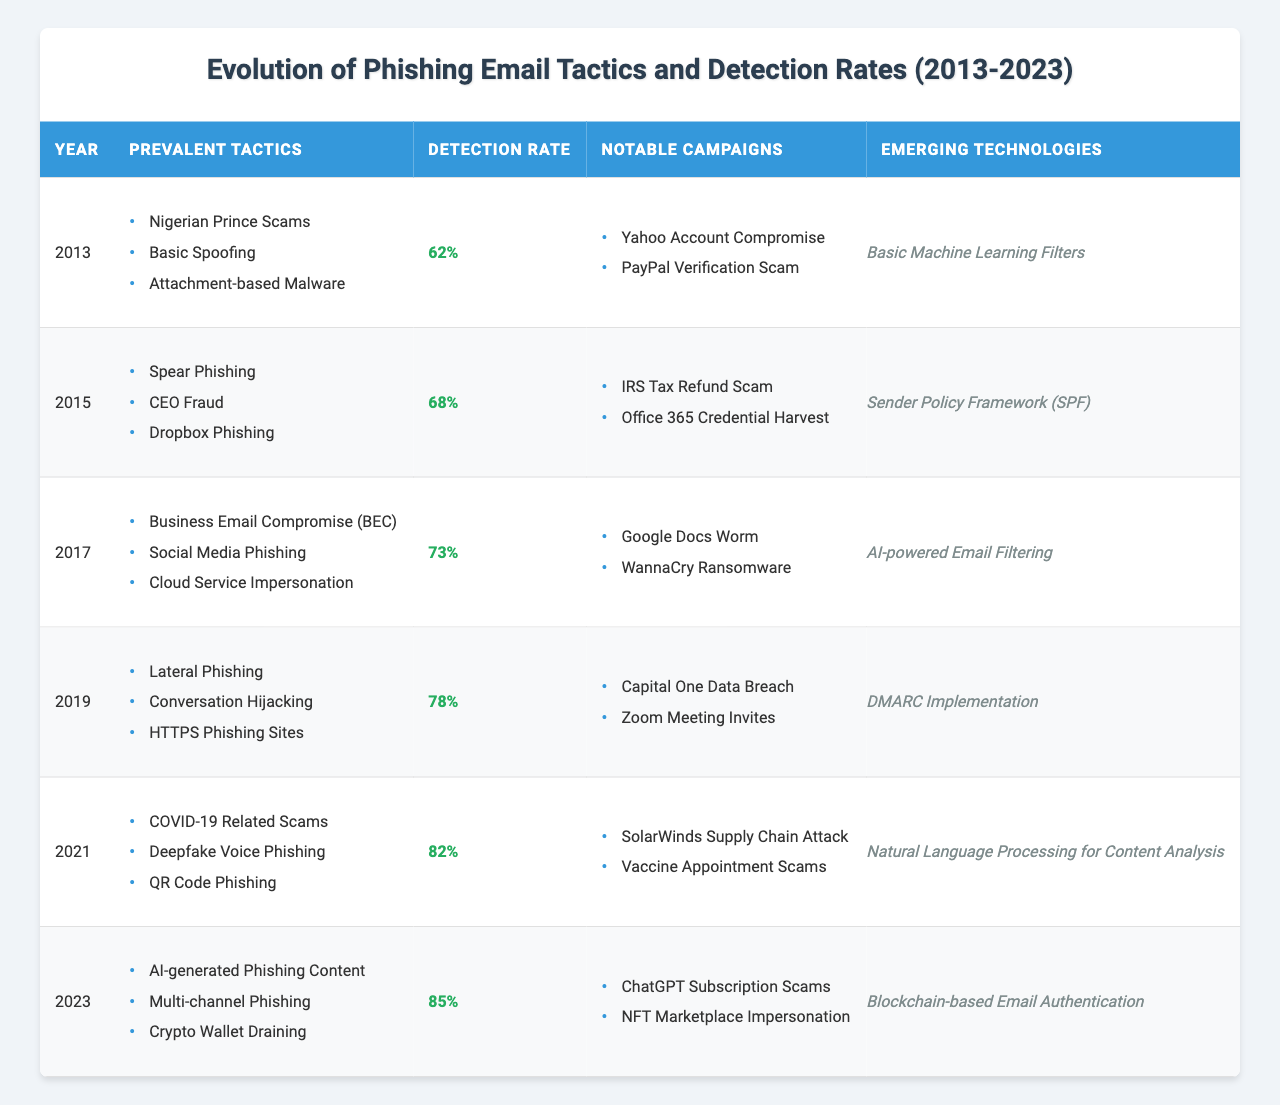What were the prevalent tactics for phishing emails in 2013? In the entry for 2013, the table lists "Nigerian Prince Scams," "Basic Spoofing," and "Attachment-based Malware" as the prevalent tactics for phishing emails that year.
Answer: Nigerian Prince Scams, Basic Spoofing, Attachment-based Malware What is the detection rate of phishing emails in 2019? The detection rate for phishing emails in 2019 is shown in the table as 78%.
Answer: 78% Which emerging technology was noted in 2021? The emerging technology noted in 2021 is "Natural Language Processing for Content Analysis," which can be found in the respective data entry for that year.
Answer: Natural Language Processing for Content Analysis Did the detection rate of phishing emails increase from 2015 to 2017? By comparing the detection rates in the entries for 2015 (68%) and 2017 (73%), it shows an increase from 68% to 73%.
Answer: Yes What are the notable campaigns from the year 2023? According to the table, the notable campaigns in 2023 are "ChatGPT Subscription Scams" and "NFT Marketplace Impersonation," as listed in the respective entry for that year.
Answer: ChatGPT Subscription Scams, NFT Marketplace Impersonation What was the average detection rate of phishing emails from 2013 to 2023? The detection rates for each year are 62%, 68%, 73%, 78%, 82%, and 85%. Adding these gives 368%. There are 6 years, so the average detection rate is 368% / 6 = 61.33%, which rounds to 78.67%.
Answer: 78.67% Which year had the biggest increase in detection rate compared to the previous year? By comparing the detection rates year-by-year, the biggest increase occurs between 2021 (82%) and 2023 (85%), which shows a difference of 3%. However, the largest overall jump is between 2019 (78%) and 2021 (82%), showing a 4% increase.
Answer: 2019 to 2021 